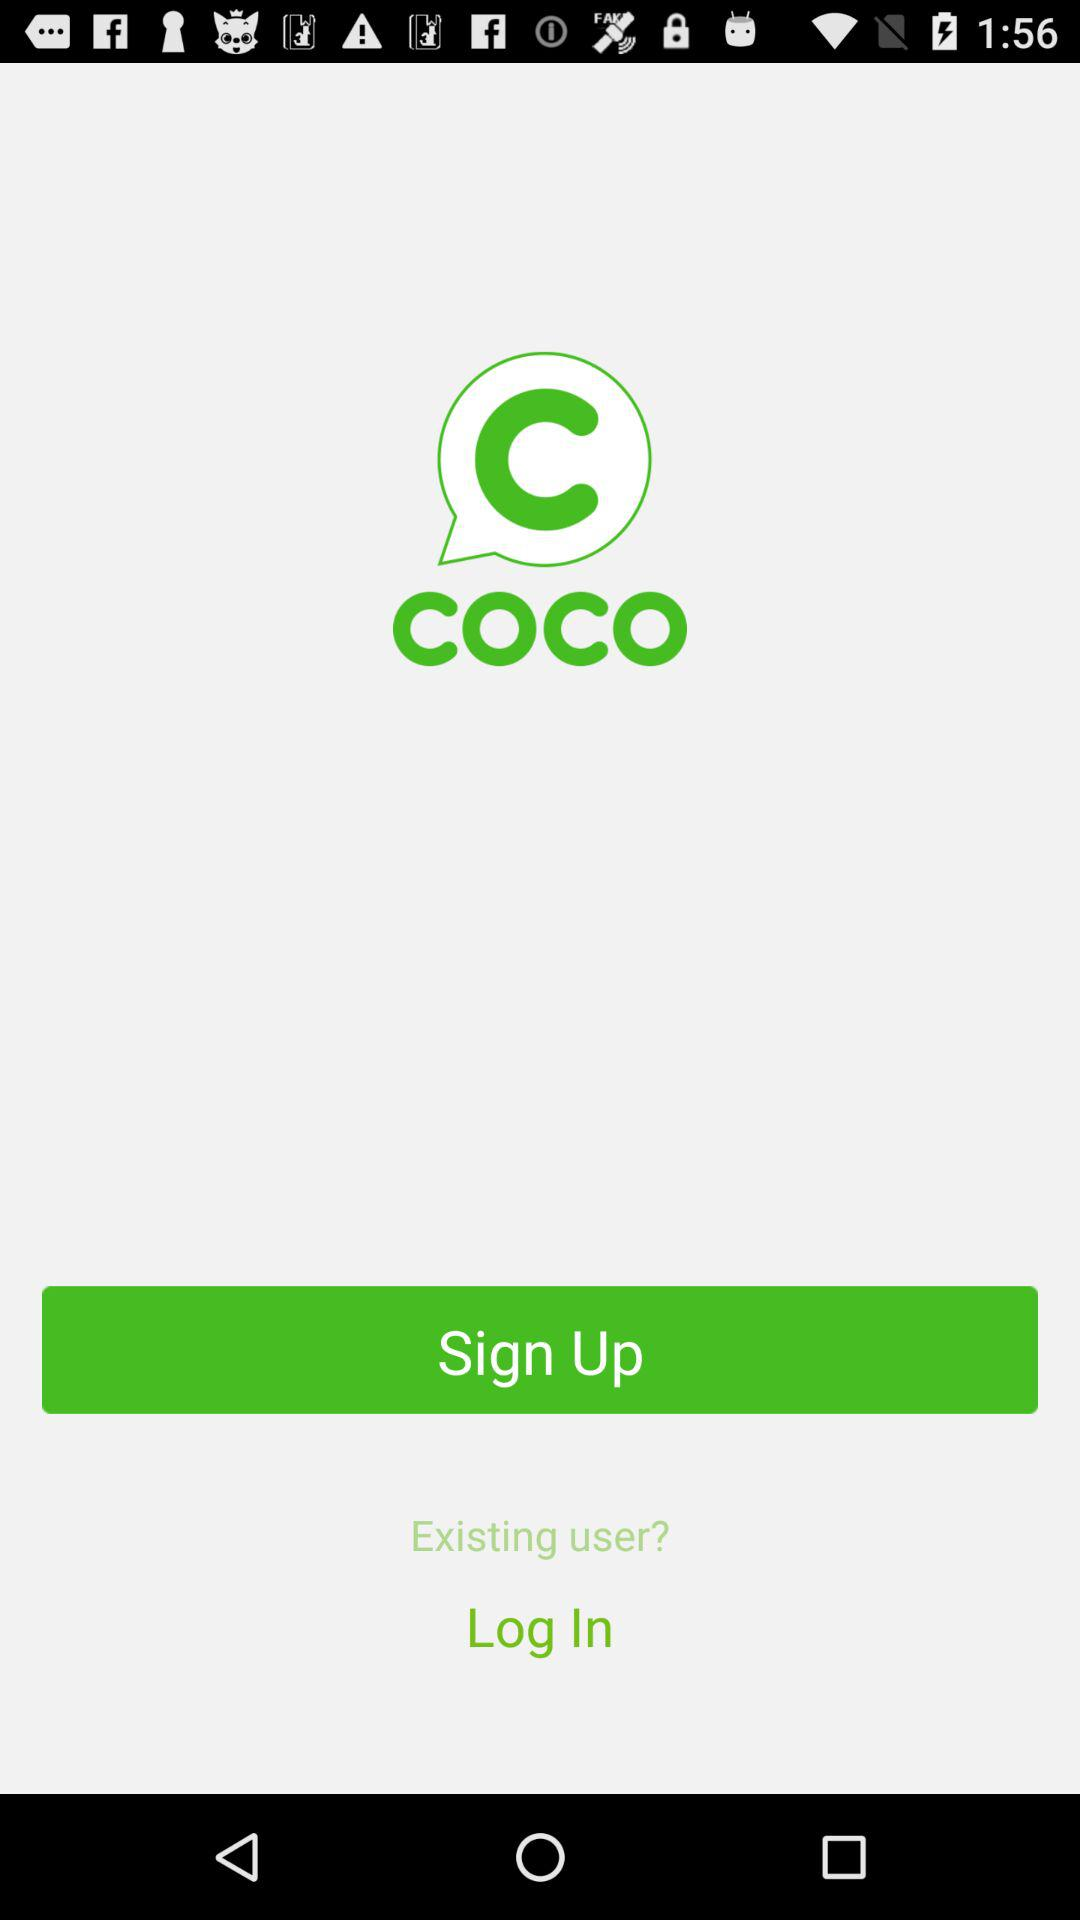What is the application name? The application name is "COCO". 